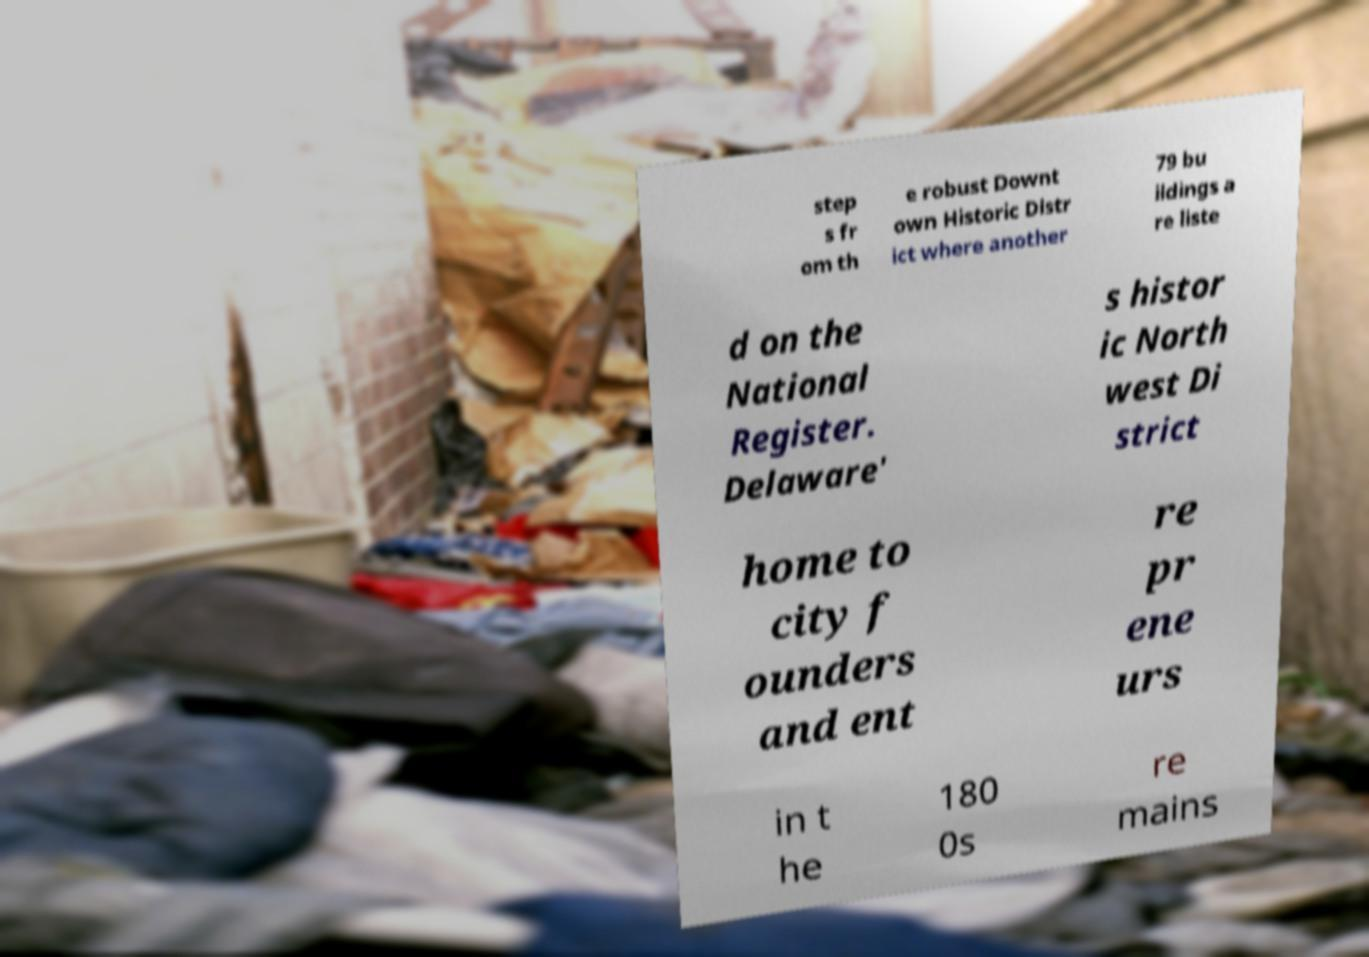I need the written content from this picture converted into text. Can you do that? step s fr om th e robust Downt own Historic Distr ict where another 79 bu ildings a re liste d on the National Register. Delaware' s histor ic North west Di strict home to city f ounders and ent re pr ene urs in t he 180 0s re mains 